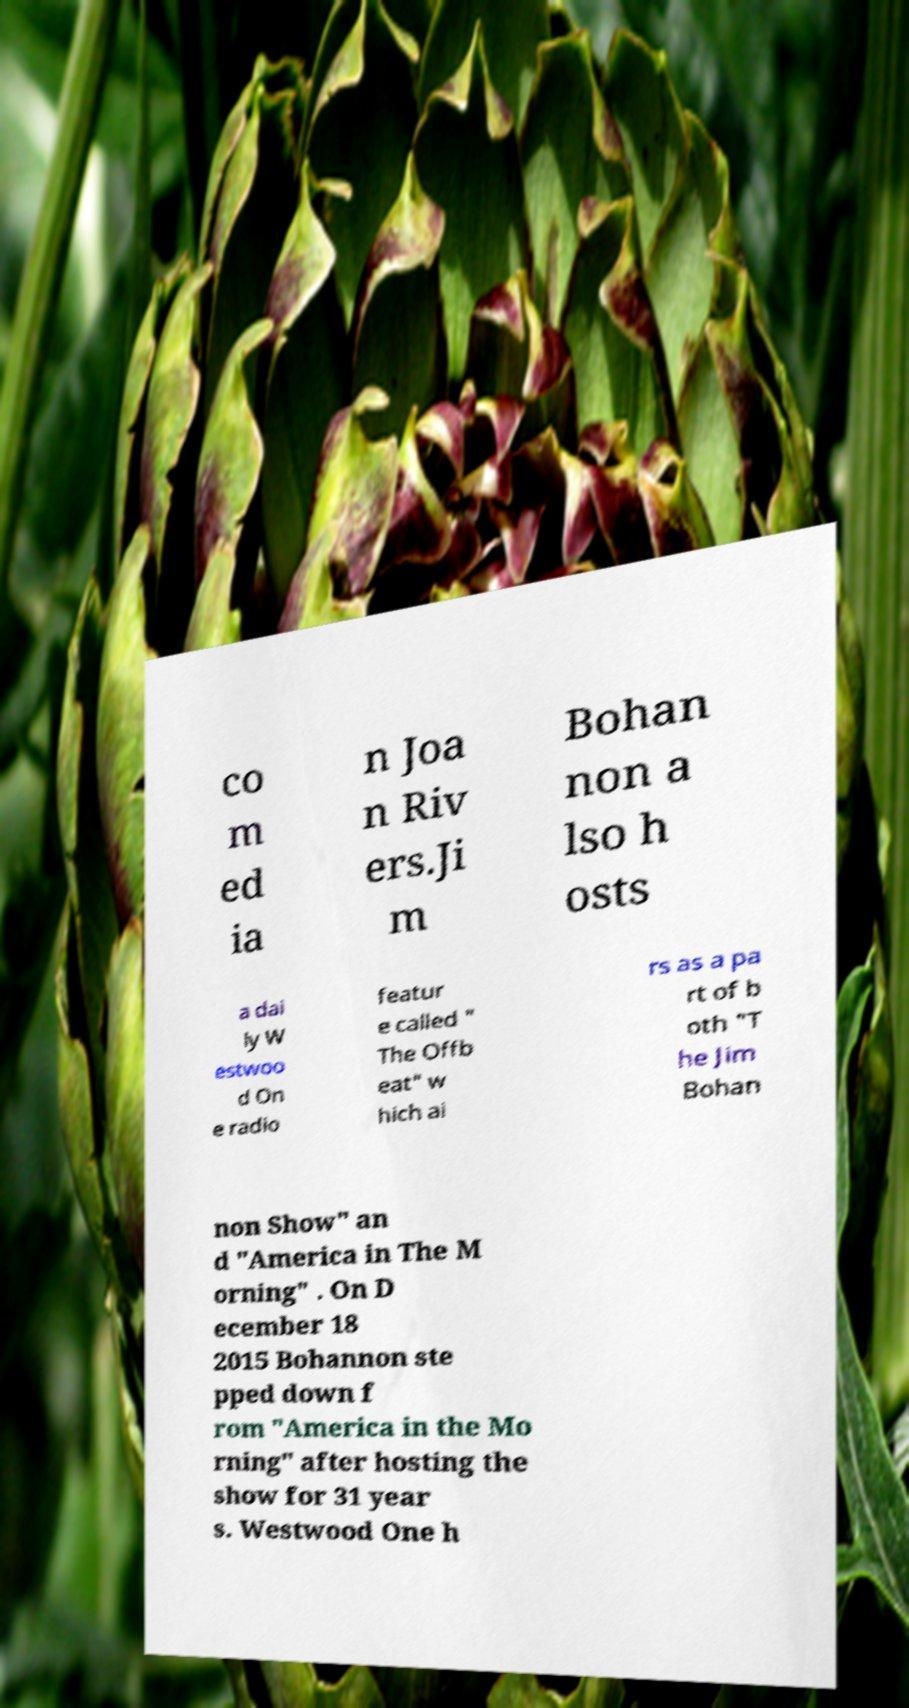Could you assist in decoding the text presented in this image and type it out clearly? co m ed ia n Joa n Riv ers.Ji m Bohan non a lso h osts a dai ly W estwoo d On e radio featur e called " The Offb eat" w hich ai rs as a pa rt of b oth "T he Jim Bohan non Show" an d "America in The M orning" . On D ecember 18 2015 Bohannon ste pped down f rom "America in the Mo rning" after hosting the show for 31 year s. Westwood One h 